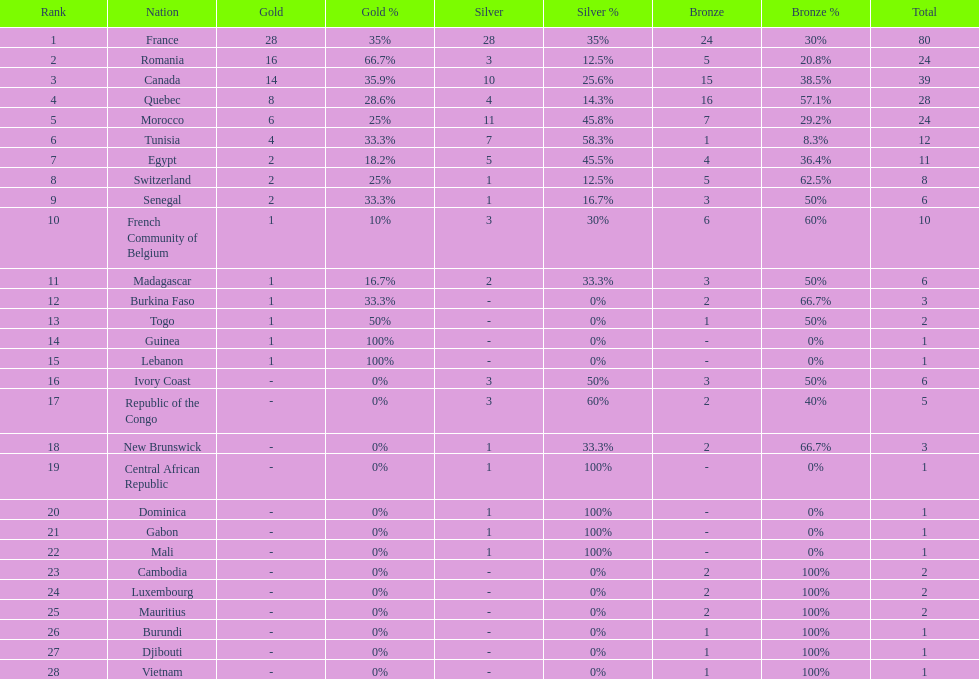How many counties have at least one silver medal? 18. Help me parse the entirety of this table. {'header': ['Rank', 'Nation', 'Gold', 'Gold %', 'Silver', 'Silver %', 'Bronze', 'Bronze %', 'Total'], 'rows': [['1', 'France', '28', '35%', '28', '35%', '24', '30%', '80'], ['2', 'Romania', '16', '66.7%', '3', '12.5%', '5', '20.8%', '24'], ['3', 'Canada', '14', '35.9%', '10', '25.6%', '15', '38.5%', '39'], ['4', 'Quebec', '8', '28.6%', '4', '14.3%', '16', '57.1%', '28'], ['5', 'Morocco', '6', '25%', '11', '45.8%', '7', '29.2%', '24'], ['6', 'Tunisia', '4', '33.3%', '7', '58.3%', '1', '8.3%', '12'], ['7', 'Egypt', '2', '18.2%', '5', '45.5%', '4', '36.4%', '11'], ['8', 'Switzerland', '2', '25%', '1', '12.5%', '5', '62.5%', '8'], ['9', 'Senegal', '2', '33.3%', '1', '16.7%', '3', '50%', '6'], ['10', 'French Community of Belgium', '1', '10%', '3', '30%', '6', '60%', '10'], ['11', 'Madagascar', '1', '16.7%', '2', '33.3%', '3', '50%', '6'], ['12', 'Burkina Faso', '1', '33.3%', '-', '0%', '2', '66.7%', '3'], ['13', 'Togo', '1', '50%', '-', '0%', '1', '50%', '2'], ['14', 'Guinea', '1', '100%', '-', '0%', '-', '0%', '1'], ['15', 'Lebanon', '1', '100%', '-', '0%', '-', '0%', '1'], ['16', 'Ivory Coast', '-', '0%', '3', '50%', '3', '50%', '6'], ['17', 'Republic of the Congo', '-', '0%', '3', '60%', '2', '40%', '5'], ['18', 'New Brunswick', '-', '0%', '1', '33.3%', '2', '66.7%', '3'], ['19', 'Central African Republic', '-', '0%', '1', '100%', '-', '0%', '1'], ['20', 'Dominica', '-', '0%', '1', '100%', '-', '0%', '1'], ['21', 'Gabon', '-', '0%', '1', '100%', '-', '0%', '1'], ['22', 'Mali', '-', '0%', '1', '100%', '-', '0%', '1'], ['23', 'Cambodia', '-', '0%', '-', '0%', '2', '100%', '2'], ['24', 'Luxembourg', '-', '0%', '-', '0%', '2', '100%', '2'], ['25', 'Mauritius', '-', '0%', '-', '0%', '2', '100%', '2'], ['26', 'Burundi', '-', '0%', '-', '0%', '1', '100%', '1'], ['27', 'Djibouti', '-', '0%', '-', '0%', '1', '100%', '1'], ['28', 'Vietnam', '-', '0%', '-', '0%', '1', '100%', '1']]} 